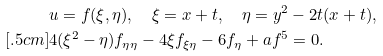<formula> <loc_0><loc_0><loc_500><loc_500>& u = f ( \xi , \eta ) , \quad \xi = x + t , \quad \eta = y ^ { 2 } - 2 t ( x + t ) , \\ [ . 5 c m ] & 4 ( \xi ^ { 2 } - \eta ) f _ { \eta \eta } - 4 \xi f _ { \xi \eta } - 6 f _ { \eta } + a f ^ { 5 } = 0 .</formula> 